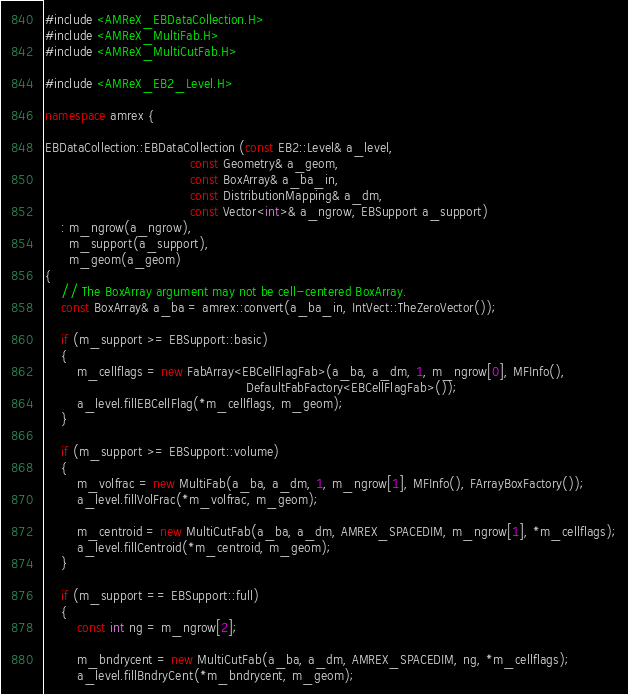<code> <loc_0><loc_0><loc_500><loc_500><_C++_>
#include <AMReX_EBDataCollection.H>
#include <AMReX_MultiFab.H>
#include <AMReX_MultiCutFab.H>

#include <AMReX_EB2_Level.H>

namespace amrex {

EBDataCollection::EBDataCollection (const EB2::Level& a_level,
                                    const Geometry& a_geom,
                                    const BoxArray& a_ba_in,
                                    const DistributionMapping& a_dm,
                                    const Vector<int>& a_ngrow, EBSupport a_support)
    : m_ngrow(a_ngrow),
      m_support(a_support),
      m_geom(a_geom)
{
    // The BoxArray argument may not be cell-centered BoxArray.
    const BoxArray& a_ba = amrex::convert(a_ba_in, IntVect::TheZeroVector());

    if (m_support >= EBSupport::basic)
    {
        m_cellflags = new FabArray<EBCellFlagFab>(a_ba, a_dm, 1, m_ngrow[0], MFInfo(),
                                                  DefaultFabFactory<EBCellFlagFab>());
        a_level.fillEBCellFlag(*m_cellflags, m_geom);
    }

    if (m_support >= EBSupport::volume)
    {
        m_volfrac = new MultiFab(a_ba, a_dm, 1, m_ngrow[1], MFInfo(), FArrayBoxFactory());
        a_level.fillVolFrac(*m_volfrac, m_geom);

        m_centroid = new MultiCutFab(a_ba, a_dm, AMREX_SPACEDIM, m_ngrow[1], *m_cellflags);
        a_level.fillCentroid(*m_centroid, m_geom);
    }

    if (m_support == EBSupport::full)
    {
        const int ng = m_ngrow[2];

        m_bndrycent = new MultiCutFab(a_ba, a_dm, AMREX_SPACEDIM, ng, *m_cellflags);
        a_level.fillBndryCent(*m_bndrycent, m_geom);
</code> 